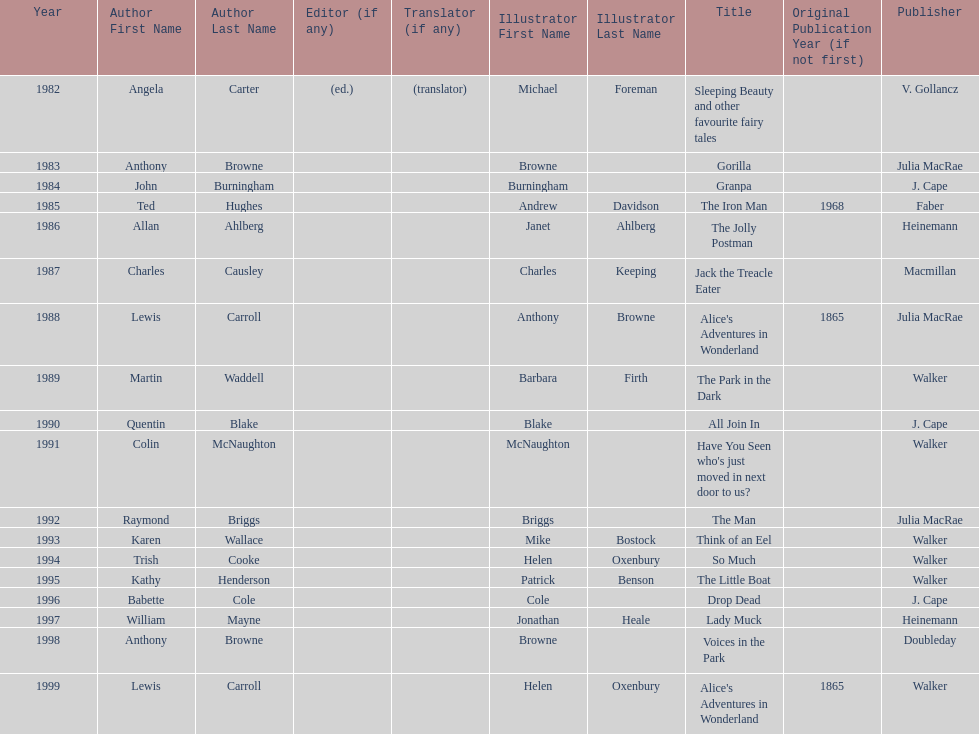How many number of titles are listed for the year 1991? 1. 